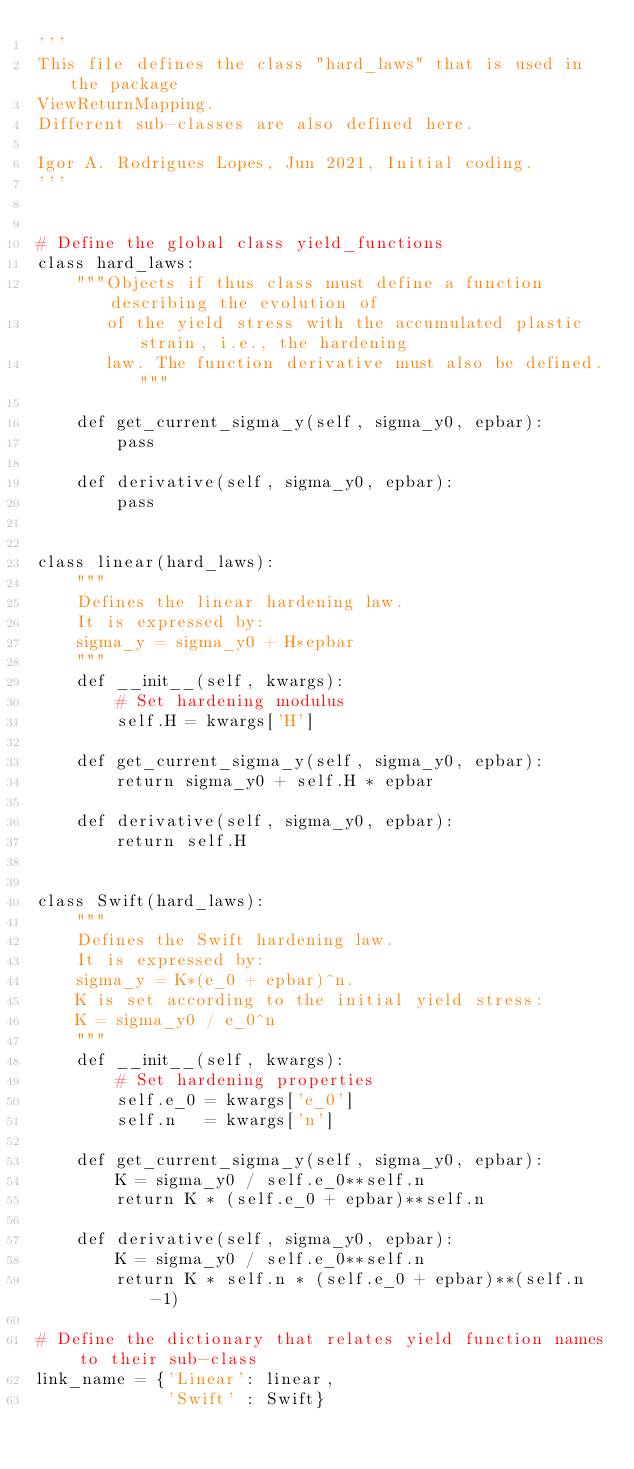Convert code to text. <code><loc_0><loc_0><loc_500><loc_500><_Python_>'''
This file defines the class "hard_laws" that is used in the package
ViewReturnMapping.
Different sub-classes are also defined here.

Igor A. Rodrigues Lopes, Jun 2021, Initial coding.
'''


# Define the global class yield_functions
class hard_laws:
    """Objects if thus class must define a function describing the evolution of
       of the yield stress with the accumulated plastic strain, i.e., the hardening
       law. The function derivative must also be defined."""

    def get_current_sigma_y(self, sigma_y0, epbar):
        pass

    def derivative(self, sigma_y0, epbar):
        pass


class linear(hard_laws):
    """
    Defines the linear hardening law.
    It is expressed by:
    sigma_y = sigma_y0 + H*epbar
    """
    def __init__(self, kwargs):
        # Set hardening modulus
        self.H = kwargs['H']

    def get_current_sigma_y(self, sigma_y0, epbar):
        return sigma_y0 + self.H * epbar

    def derivative(self, sigma_y0, epbar):
        return self.H


class Swift(hard_laws):
    """
    Defines the Swift hardening law.
    It is expressed by:
    sigma_y = K*(e_0 + epbar)^n.
    K is set according to the initial yield stress:
    K = sigma_y0 / e_0^n
    """
    def __init__(self, kwargs):
        # Set hardening properties
        self.e_0 = kwargs['e_0']
        self.n   = kwargs['n']

    def get_current_sigma_y(self, sigma_y0, epbar):
        K = sigma_y0 / self.e_0**self.n
        return K * (self.e_0 + epbar)**self.n

    def derivative(self, sigma_y0, epbar):
        K = sigma_y0 / self.e_0**self.n
        return K * self.n * (self.e_0 + epbar)**(self.n-1)
        
# Define the dictionary that relates yield function names to their sub-class
link_name = {'Linear': linear,
             'Swift' : Swift}
</code> 